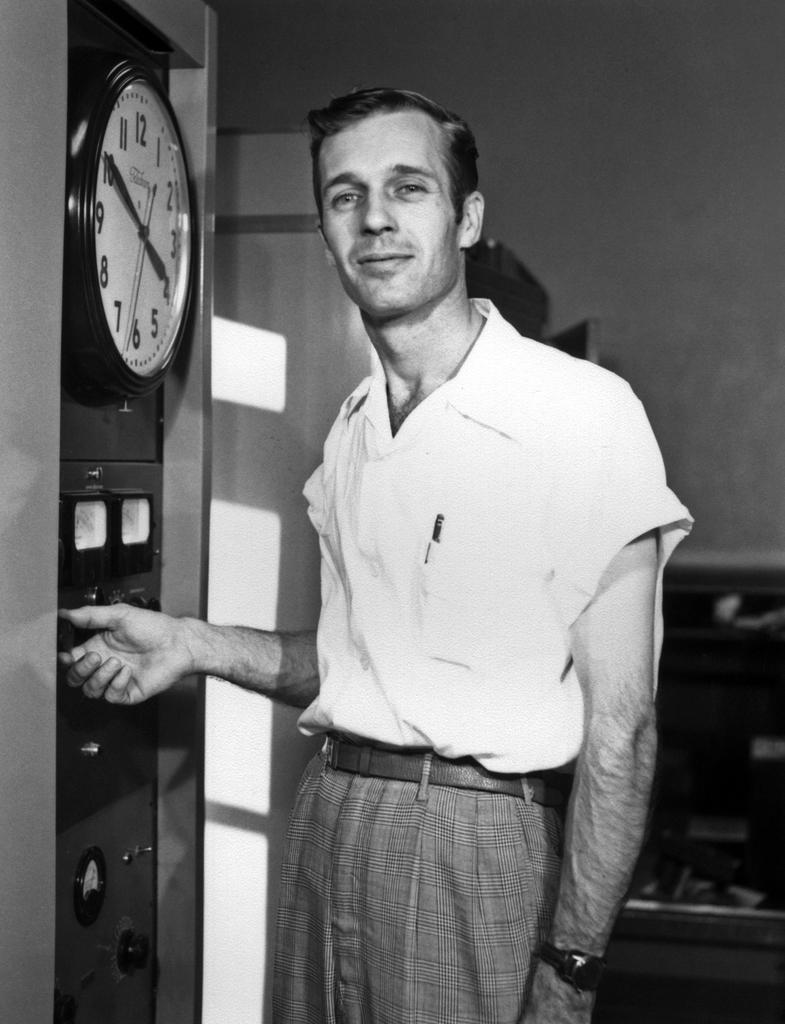<image>
Summarize the visual content of the image. A man wearing a white shirt stands next to a clock with a time of 4:50 showing on it. 